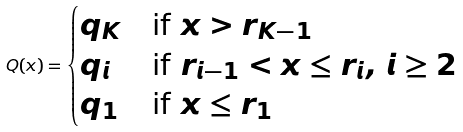<formula> <loc_0><loc_0><loc_500><loc_500>Q ( x ) = \begin{cases} q _ { K } & \text {if } x > r _ { K - 1 } \\ q _ { i } & \text {if } r _ { i - 1 } < x \leq r _ { i } , \, i \geq 2 \\ q _ { 1 } & \text {if } x \leq r _ { 1 } \end{cases}</formula> 